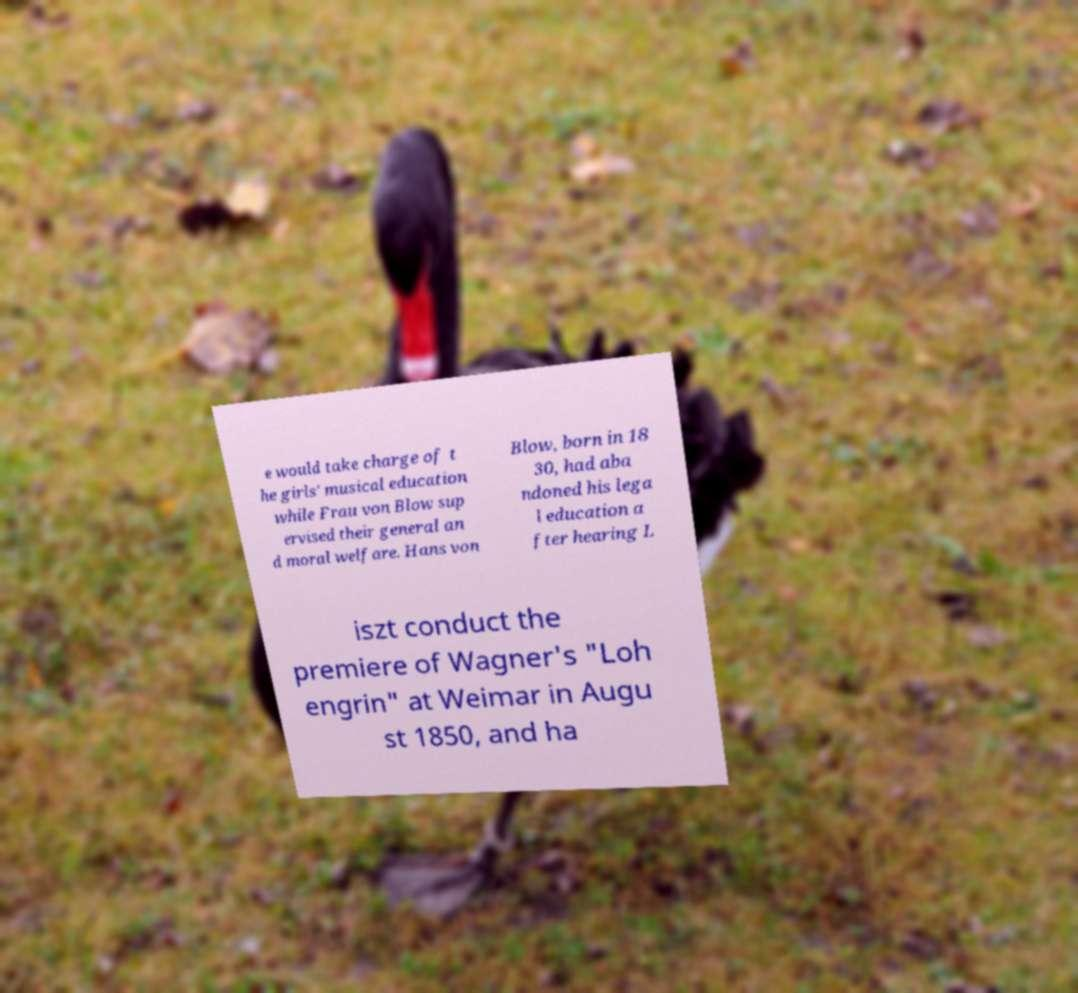Could you assist in decoding the text presented in this image and type it out clearly? e would take charge of t he girls' musical education while Frau von Blow sup ervised their general an d moral welfare. Hans von Blow, born in 18 30, had aba ndoned his lega l education a fter hearing L iszt conduct the premiere of Wagner's "Loh engrin" at Weimar in Augu st 1850, and ha 